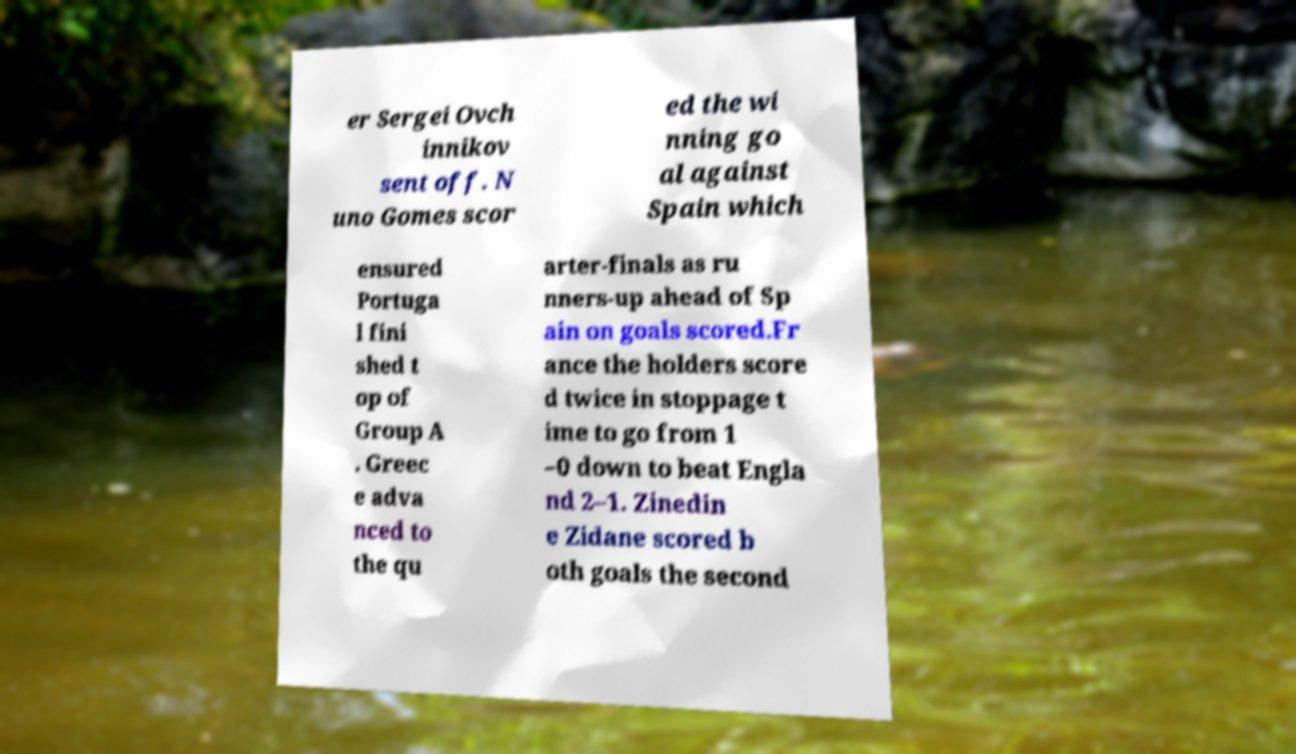For documentation purposes, I need the text within this image transcribed. Could you provide that? er Sergei Ovch innikov sent off. N uno Gomes scor ed the wi nning go al against Spain which ensured Portuga l fini shed t op of Group A . Greec e adva nced to the qu arter-finals as ru nners-up ahead of Sp ain on goals scored.Fr ance the holders score d twice in stoppage t ime to go from 1 –0 down to beat Engla nd 2–1. Zinedin e Zidane scored b oth goals the second 